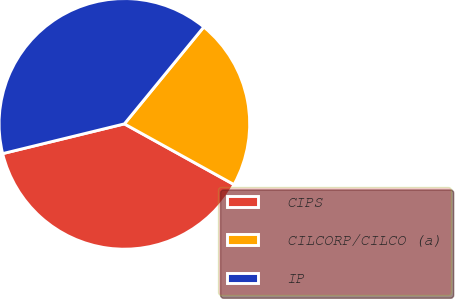<chart> <loc_0><loc_0><loc_500><loc_500><pie_chart><fcel>CIPS<fcel>CILCORP/CILCO (a)<fcel>IP<nl><fcel>38.14%<fcel>22.12%<fcel>39.74%<nl></chart> 